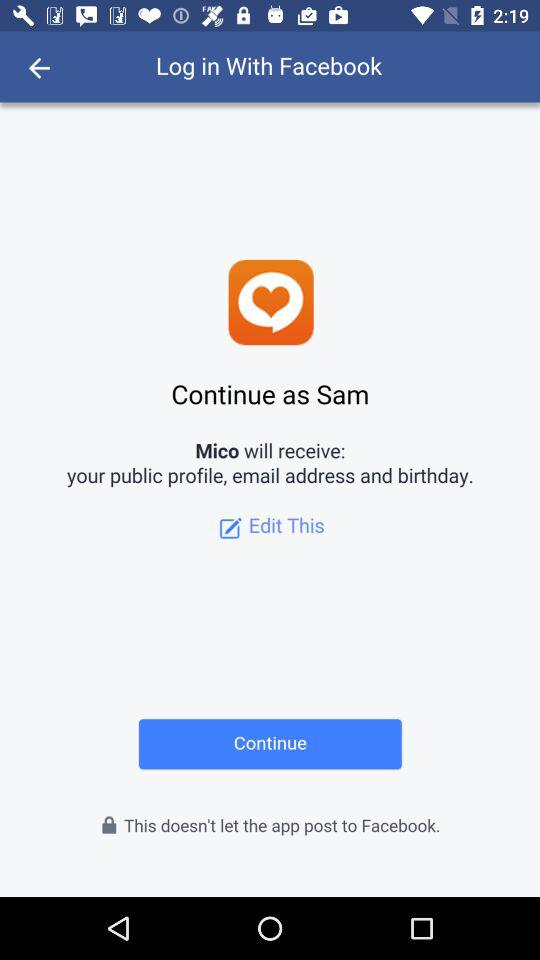What is the user name? The user name is Sam. 